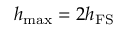Convert formula to latex. <formula><loc_0><loc_0><loc_500><loc_500>h _ { \max } = 2 h _ { F S }</formula> 